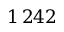Convert formula to latex. <formula><loc_0><loc_0><loc_500><loc_500>1 \, 2 4 2</formula> 